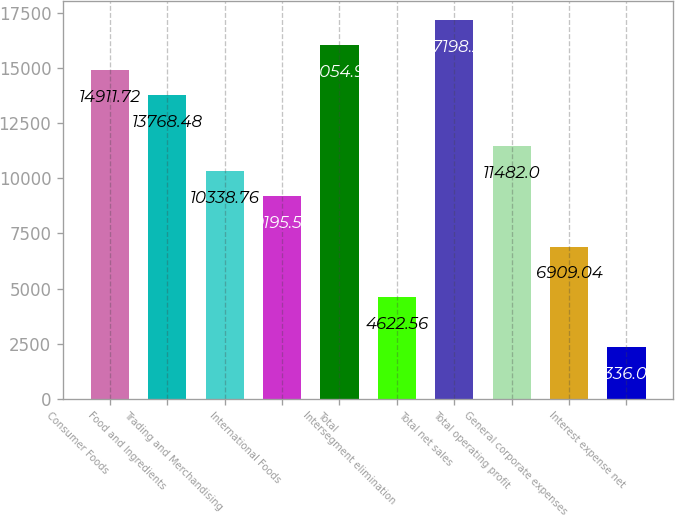Convert chart to OTSL. <chart><loc_0><loc_0><loc_500><loc_500><bar_chart><fcel>Consumer Foods<fcel>Food and Ingredients<fcel>Trading and Merchandising<fcel>International Foods<fcel>Total<fcel>Intersegment elimination<fcel>Total net sales<fcel>Total operating profit<fcel>General corporate expenses<fcel>Interest expense net<nl><fcel>14911.7<fcel>13768.5<fcel>10338.8<fcel>9195.52<fcel>16055<fcel>4622.56<fcel>17198.2<fcel>11482<fcel>6909.04<fcel>2336.08<nl></chart> 